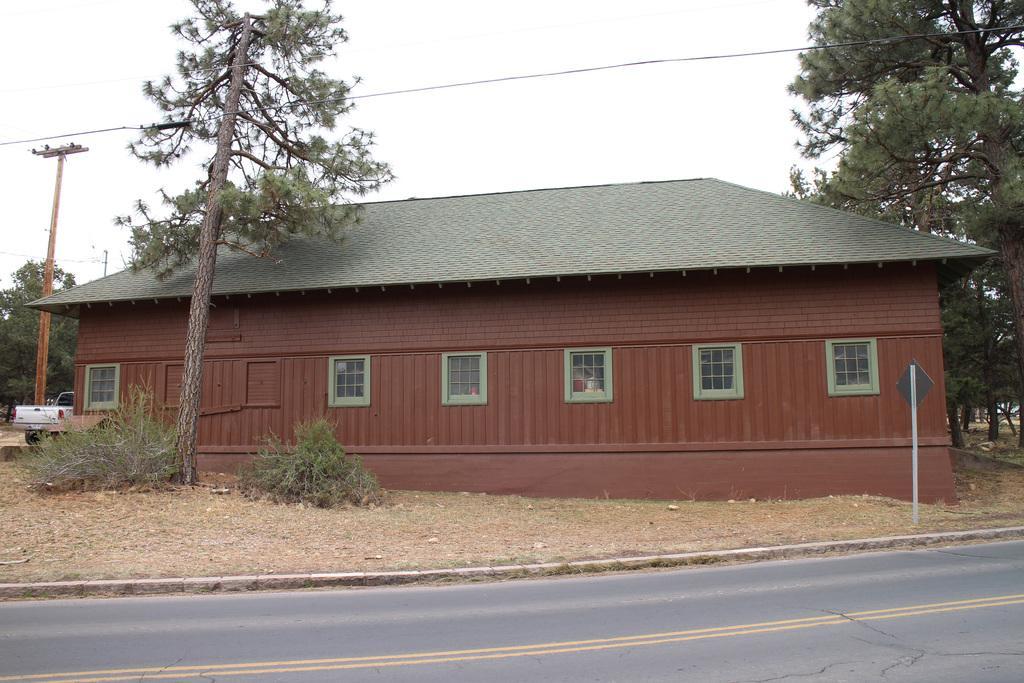In one or two sentences, can you explain what this image depicts? Here there is a house with the windows, here there are trees, there is a vehicle, this is road. 